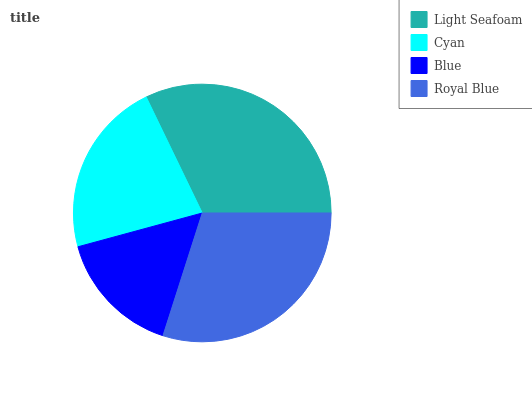Is Blue the minimum?
Answer yes or no. Yes. Is Light Seafoam the maximum?
Answer yes or no. Yes. Is Cyan the minimum?
Answer yes or no. No. Is Cyan the maximum?
Answer yes or no. No. Is Light Seafoam greater than Cyan?
Answer yes or no. Yes. Is Cyan less than Light Seafoam?
Answer yes or no. Yes. Is Cyan greater than Light Seafoam?
Answer yes or no. No. Is Light Seafoam less than Cyan?
Answer yes or no. No. Is Royal Blue the high median?
Answer yes or no. Yes. Is Cyan the low median?
Answer yes or no. Yes. Is Cyan the high median?
Answer yes or no. No. Is Royal Blue the low median?
Answer yes or no. No. 